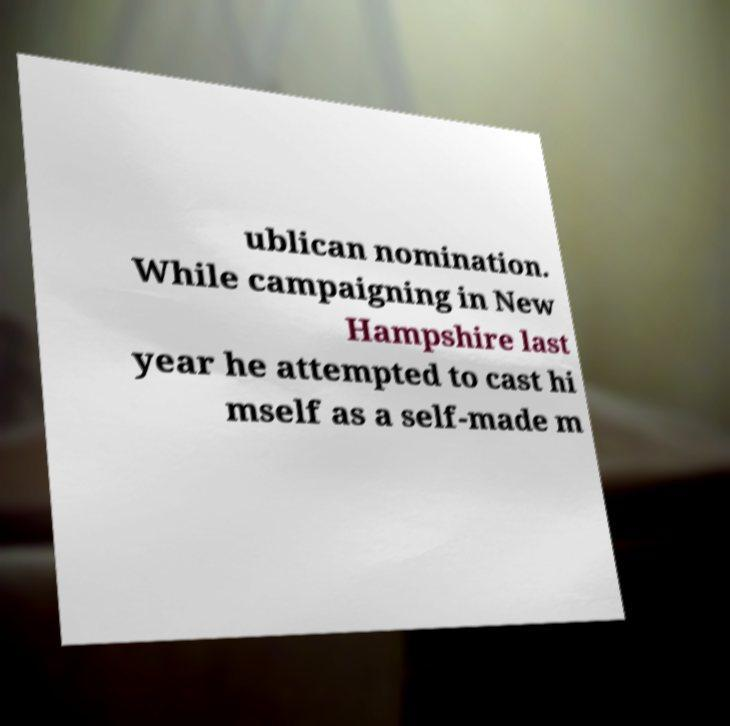Can you accurately transcribe the text from the provided image for me? ublican nomination. While campaigning in New Hampshire last year he attempted to cast hi mself as a self-made m 